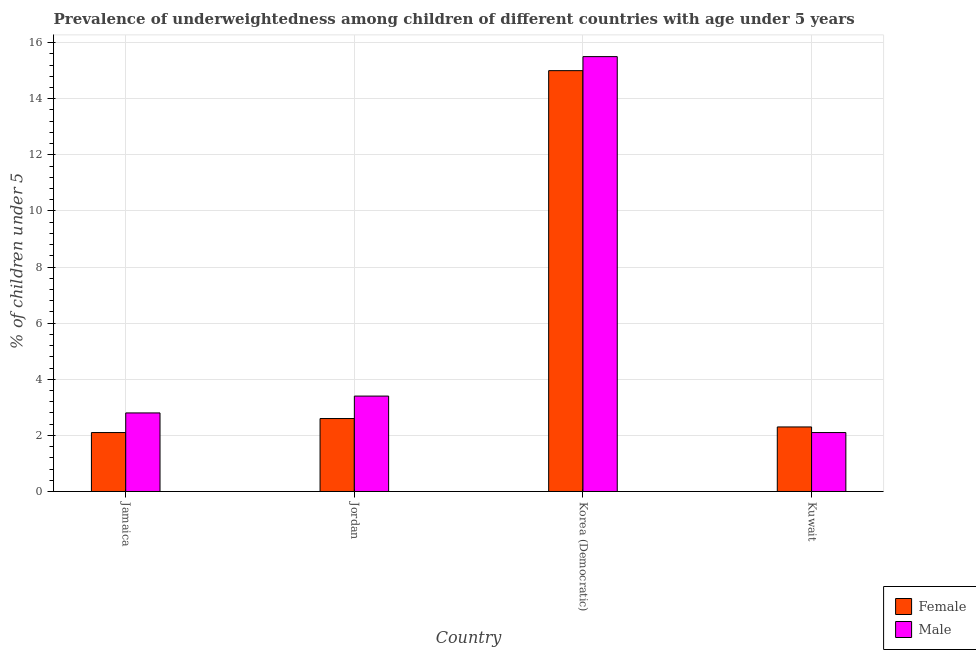How many groups of bars are there?
Keep it short and to the point. 4. Are the number of bars on each tick of the X-axis equal?
Offer a terse response. Yes. How many bars are there on the 1st tick from the right?
Provide a succinct answer. 2. What is the label of the 3rd group of bars from the left?
Your answer should be very brief. Korea (Democratic). In how many cases, is the number of bars for a given country not equal to the number of legend labels?
Your answer should be compact. 0. What is the percentage of underweighted female children in Korea (Democratic)?
Your answer should be very brief. 15. Across all countries, what is the minimum percentage of underweighted male children?
Give a very brief answer. 2.1. In which country was the percentage of underweighted female children maximum?
Provide a succinct answer. Korea (Democratic). In which country was the percentage of underweighted female children minimum?
Your answer should be very brief. Jamaica. What is the total percentage of underweighted female children in the graph?
Ensure brevity in your answer.  22. What is the difference between the percentage of underweighted female children in Korea (Democratic) and that in Kuwait?
Offer a terse response. 12.7. What is the difference between the percentage of underweighted male children in Korea (Democratic) and the percentage of underweighted female children in Kuwait?
Provide a short and direct response. 13.2. What is the average percentage of underweighted male children per country?
Offer a very short reply. 5.95. What is the difference between the percentage of underweighted female children and percentage of underweighted male children in Jordan?
Your response must be concise. -0.8. What is the ratio of the percentage of underweighted male children in Korea (Democratic) to that in Kuwait?
Make the answer very short. 7.38. Is the percentage of underweighted male children in Jamaica less than that in Jordan?
Offer a very short reply. Yes. Is the difference between the percentage of underweighted male children in Jamaica and Jordan greater than the difference between the percentage of underweighted female children in Jamaica and Jordan?
Your answer should be very brief. No. What is the difference between the highest and the second highest percentage of underweighted female children?
Provide a short and direct response. 12.4. What is the difference between the highest and the lowest percentage of underweighted female children?
Provide a succinct answer. 12.9. In how many countries, is the percentage of underweighted male children greater than the average percentage of underweighted male children taken over all countries?
Offer a very short reply. 1. What does the 2nd bar from the left in Kuwait represents?
Provide a succinct answer. Male. What does the 1st bar from the right in Jordan represents?
Keep it short and to the point. Male. How many bars are there?
Provide a succinct answer. 8. Are all the bars in the graph horizontal?
Provide a succinct answer. No. How many countries are there in the graph?
Your response must be concise. 4. What is the difference between two consecutive major ticks on the Y-axis?
Keep it short and to the point. 2. Where does the legend appear in the graph?
Provide a short and direct response. Bottom right. How many legend labels are there?
Your answer should be very brief. 2. How are the legend labels stacked?
Keep it short and to the point. Vertical. What is the title of the graph?
Your answer should be compact. Prevalence of underweightedness among children of different countries with age under 5 years. What is the label or title of the Y-axis?
Provide a short and direct response.  % of children under 5. What is the  % of children under 5 in Female in Jamaica?
Your response must be concise. 2.1. What is the  % of children under 5 in Male in Jamaica?
Give a very brief answer. 2.8. What is the  % of children under 5 in Female in Jordan?
Your response must be concise. 2.6. What is the  % of children under 5 of Male in Jordan?
Your response must be concise. 3.4. What is the  % of children under 5 in Male in Korea (Democratic)?
Offer a terse response. 15.5. What is the  % of children under 5 in Female in Kuwait?
Provide a short and direct response. 2.3. What is the  % of children under 5 in Male in Kuwait?
Your response must be concise. 2.1. Across all countries, what is the maximum  % of children under 5 in Female?
Your response must be concise. 15. Across all countries, what is the maximum  % of children under 5 in Male?
Offer a very short reply. 15.5. Across all countries, what is the minimum  % of children under 5 in Female?
Provide a short and direct response. 2.1. Across all countries, what is the minimum  % of children under 5 in Male?
Offer a terse response. 2.1. What is the total  % of children under 5 of Male in the graph?
Provide a short and direct response. 23.8. What is the difference between the  % of children under 5 of Female in Jamaica and that in Jordan?
Give a very brief answer. -0.5. What is the difference between the  % of children under 5 of Male in Jamaica and that in Jordan?
Provide a short and direct response. -0.6. What is the difference between the  % of children under 5 in Female in Jamaica and that in Korea (Democratic)?
Give a very brief answer. -12.9. What is the difference between the  % of children under 5 of Female in Jordan and that in Korea (Democratic)?
Make the answer very short. -12.4. What is the difference between the  % of children under 5 in Male in Jordan and that in Korea (Democratic)?
Your answer should be very brief. -12.1. What is the difference between the  % of children under 5 of Male in Korea (Democratic) and that in Kuwait?
Your response must be concise. 13.4. What is the difference between the  % of children under 5 in Female in Jordan and the  % of children under 5 in Male in Kuwait?
Provide a short and direct response. 0.5. What is the difference between the  % of children under 5 in Female in Korea (Democratic) and the  % of children under 5 in Male in Kuwait?
Your answer should be compact. 12.9. What is the average  % of children under 5 of Male per country?
Make the answer very short. 5.95. What is the difference between the  % of children under 5 of Female and  % of children under 5 of Male in Jamaica?
Offer a very short reply. -0.7. What is the ratio of the  % of children under 5 of Female in Jamaica to that in Jordan?
Keep it short and to the point. 0.81. What is the ratio of the  % of children under 5 in Male in Jamaica to that in Jordan?
Provide a short and direct response. 0.82. What is the ratio of the  % of children under 5 in Female in Jamaica to that in Korea (Democratic)?
Make the answer very short. 0.14. What is the ratio of the  % of children under 5 in Male in Jamaica to that in Korea (Democratic)?
Your response must be concise. 0.18. What is the ratio of the  % of children under 5 of Female in Jamaica to that in Kuwait?
Give a very brief answer. 0.91. What is the ratio of the  % of children under 5 in Male in Jamaica to that in Kuwait?
Keep it short and to the point. 1.33. What is the ratio of the  % of children under 5 in Female in Jordan to that in Korea (Democratic)?
Ensure brevity in your answer.  0.17. What is the ratio of the  % of children under 5 in Male in Jordan to that in Korea (Democratic)?
Make the answer very short. 0.22. What is the ratio of the  % of children under 5 of Female in Jordan to that in Kuwait?
Your answer should be very brief. 1.13. What is the ratio of the  % of children under 5 in Male in Jordan to that in Kuwait?
Provide a succinct answer. 1.62. What is the ratio of the  % of children under 5 in Female in Korea (Democratic) to that in Kuwait?
Provide a succinct answer. 6.52. What is the ratio of the  % of children under 5 of Male in Korea (Democratic) to that in Kuwait?
Offer a terse response. 7.38. What is the difference between the highest and the second highest  % of children under 5 of Male?
Provide a short and direct response. 12.1. 